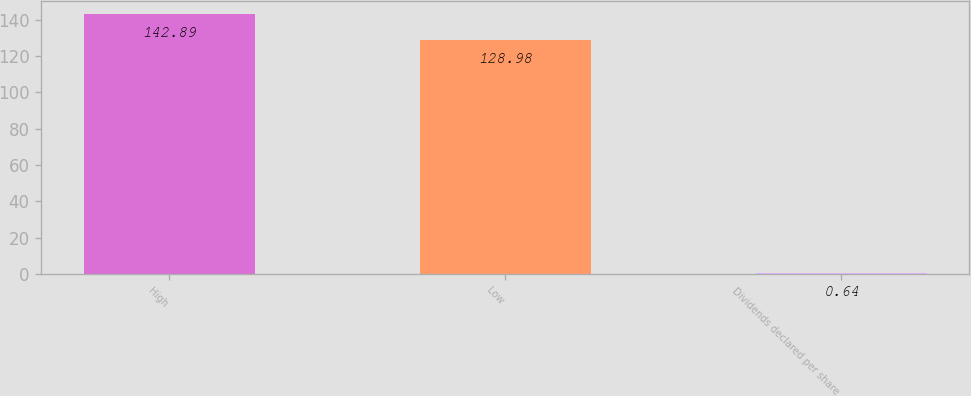<chart> <loc_0><loc_0><loc_500><loc_500><bar_chart><fcel>High<fcel>Low<fcel>Dividends declared per share<nl><fcel>142.89<fcel>128.98<fcel>0.64<nl></chart> 